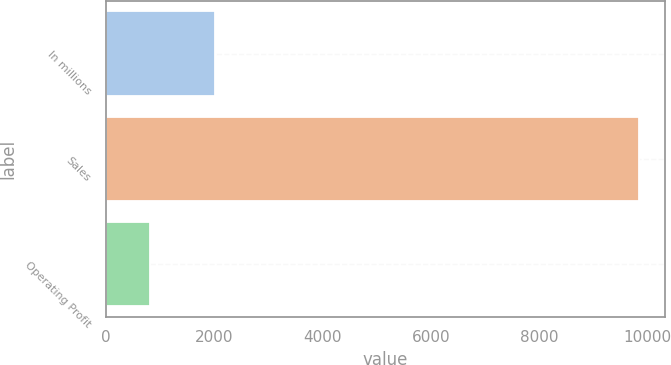Convert chart. <chart><loc_0><loc_0><loc_500><loc_500><bar_chart><fcel>In millions<fcel>Sales<fcel>Operating Profit<nl><fcel>2010<fcel>9840<fcel>826<nl></chart> 